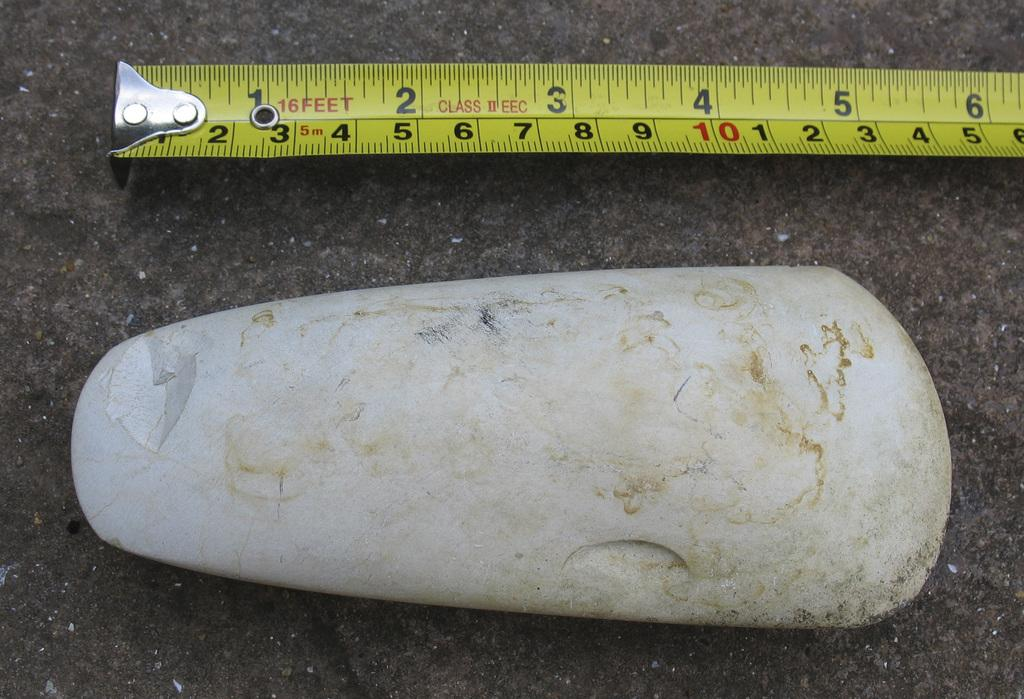What is the main subject of the image? The main subject of the image is a rock. What object is placed beside the rock in the image? There is a measuring tape beside the rock in the image. What type of creature can be seen interacting with the rock in the image? There is no creature present in the image; it only features a rock and a measuring tape. What scientific theory can be observed in the image? There is no scientific theory observable in the image; it only features a rock and a measuring tape. 